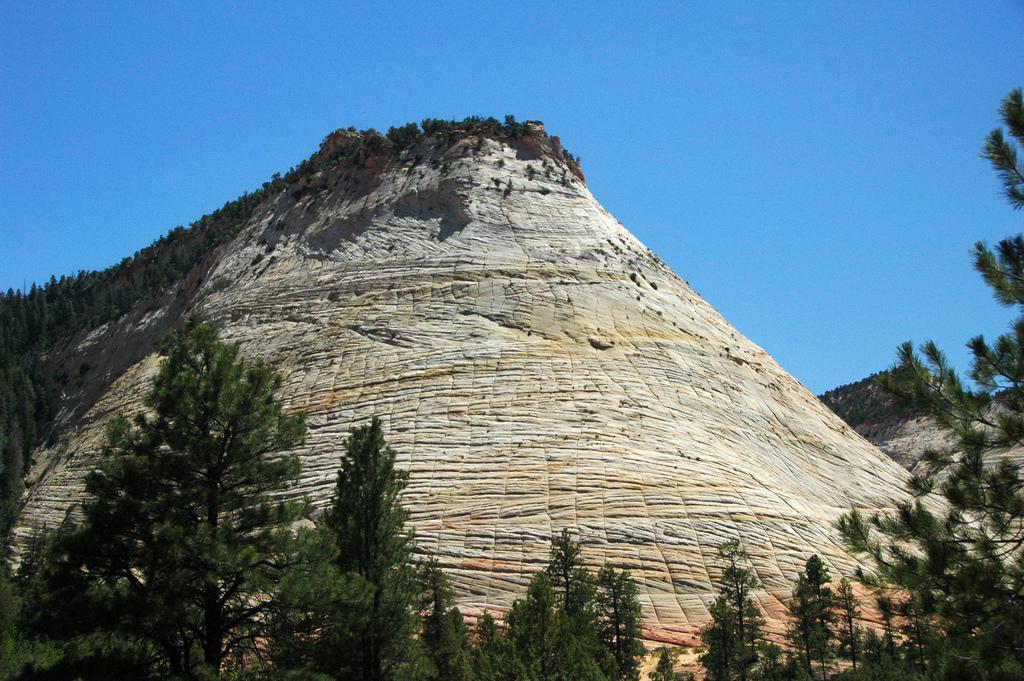Could you give a brief overview of what you see in this image? In the image there is a rock formation, it is very huge and around that there are many trees. 